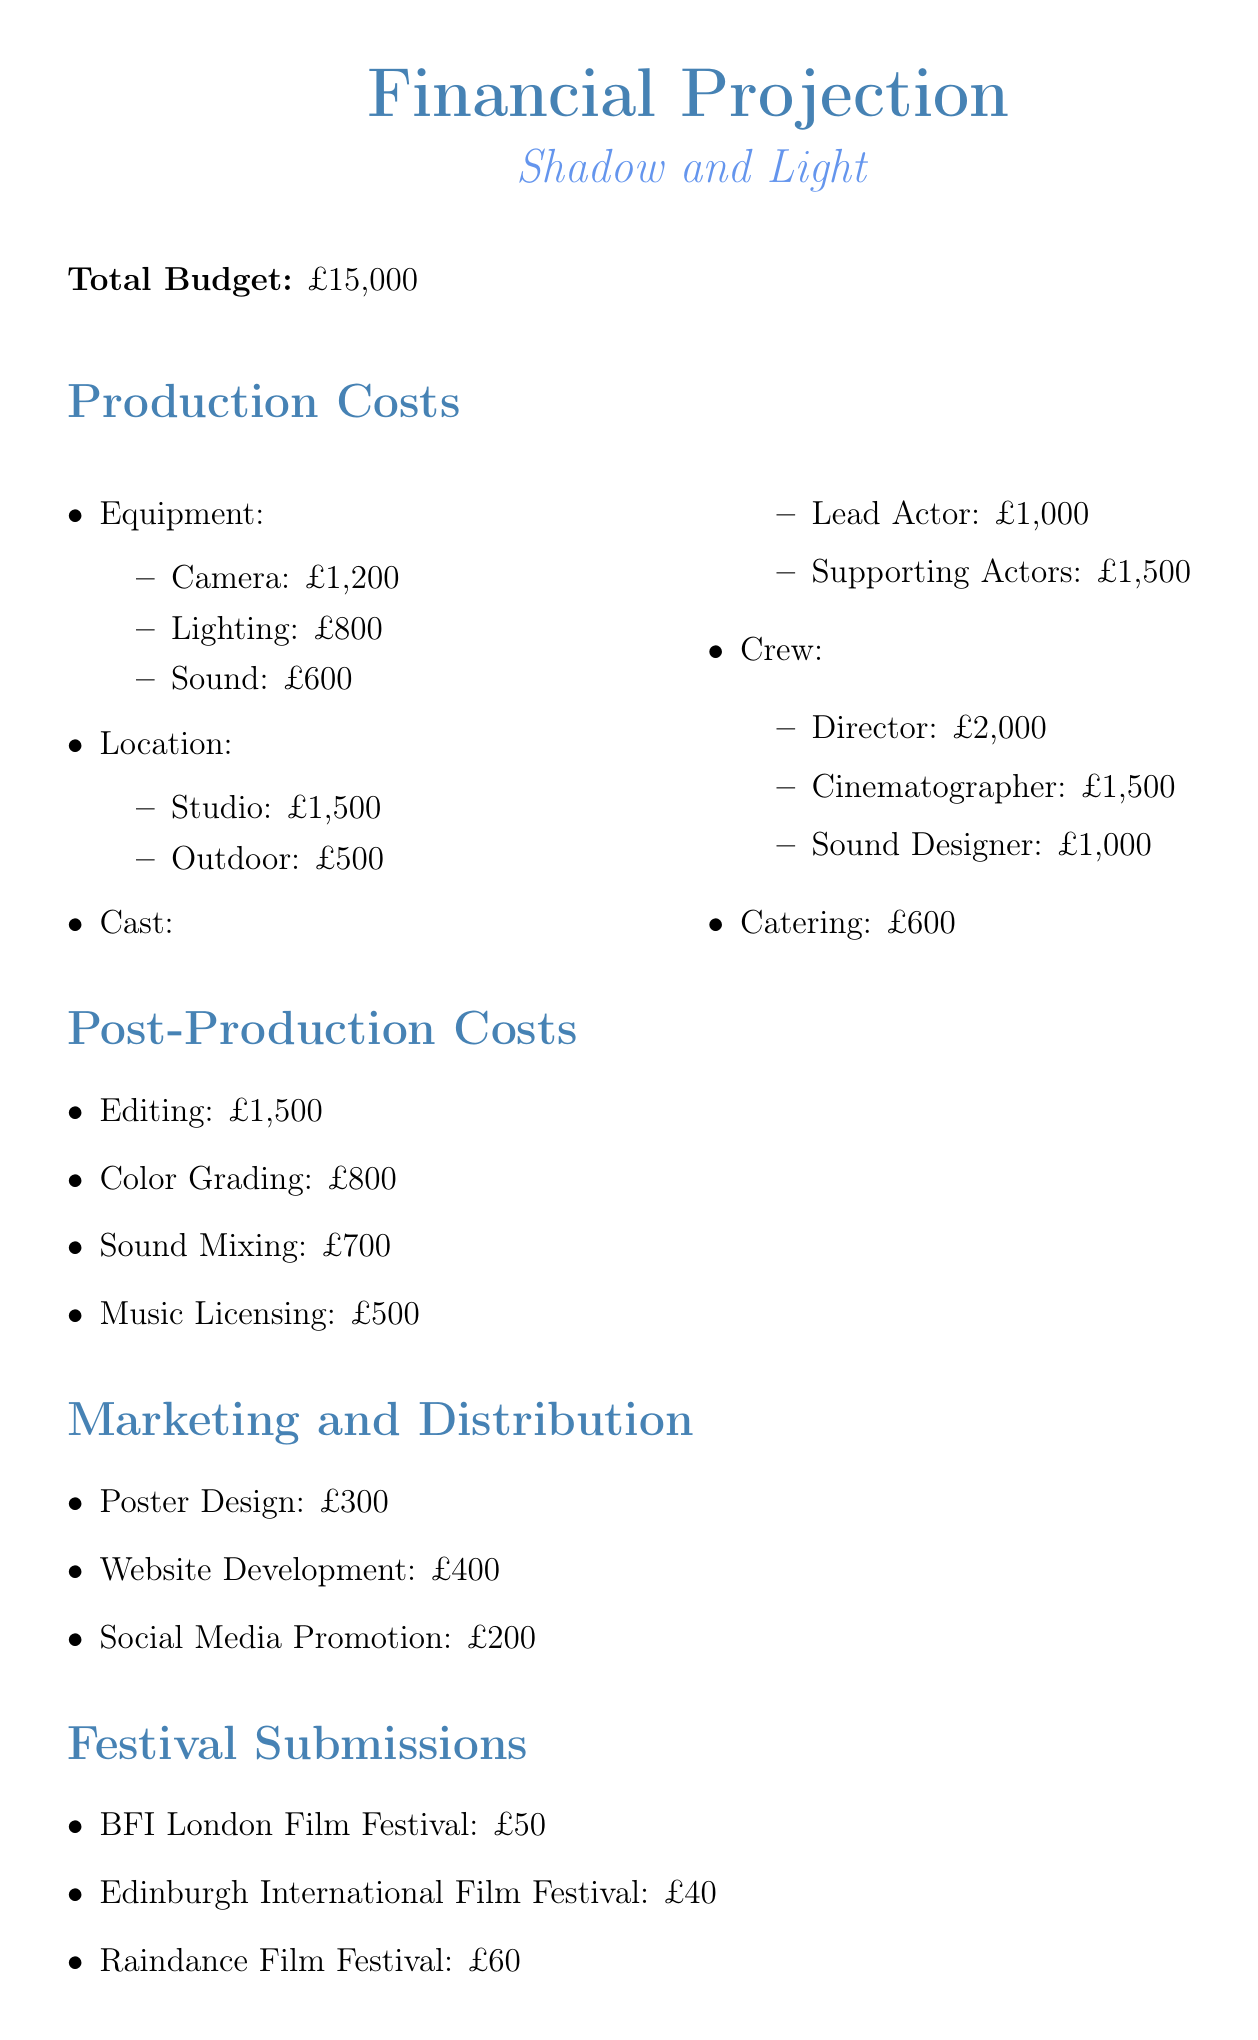What is the total budget? The total budget for the project is stated explicitly in the document.
Answer: £15,000 How much is allocated for equipment? The document specifies the budget for each category, including a total for equipment costs which includes camera, lighting, and sound expenses.
Answer: £2,600 What is the cost of the director's fee? The fee for the director is mentioned under production costs, specifically in the crew section of the document.
Answer: £2,000 What is the cost for festival submissions? The total amount for festival submissions can be found by adding each individual festival fee provided in the document.
Answer: £325 Which festival has the highest submission fee? By comparing the individual submission fees listed for each festival, one can determine which fee is the highest.
Answer: Cannes Film Festival (Short Film Corner) What are the total post-production costs? The total for post-production can be calculated by summing the individual costs laid out in that section of the document.
Answer: £3,500 How much is allocated for social media promotion? The document has a specific entry for social media promotion under the marketing and distribution section.
Answer: £200 What is the budget for catering? The budget for catering is provided explicitly in the production costs section.
Answer: £600 What is the contingency amount? The contingency amount is clearly stated towards the end of the document.
Answer: £625 